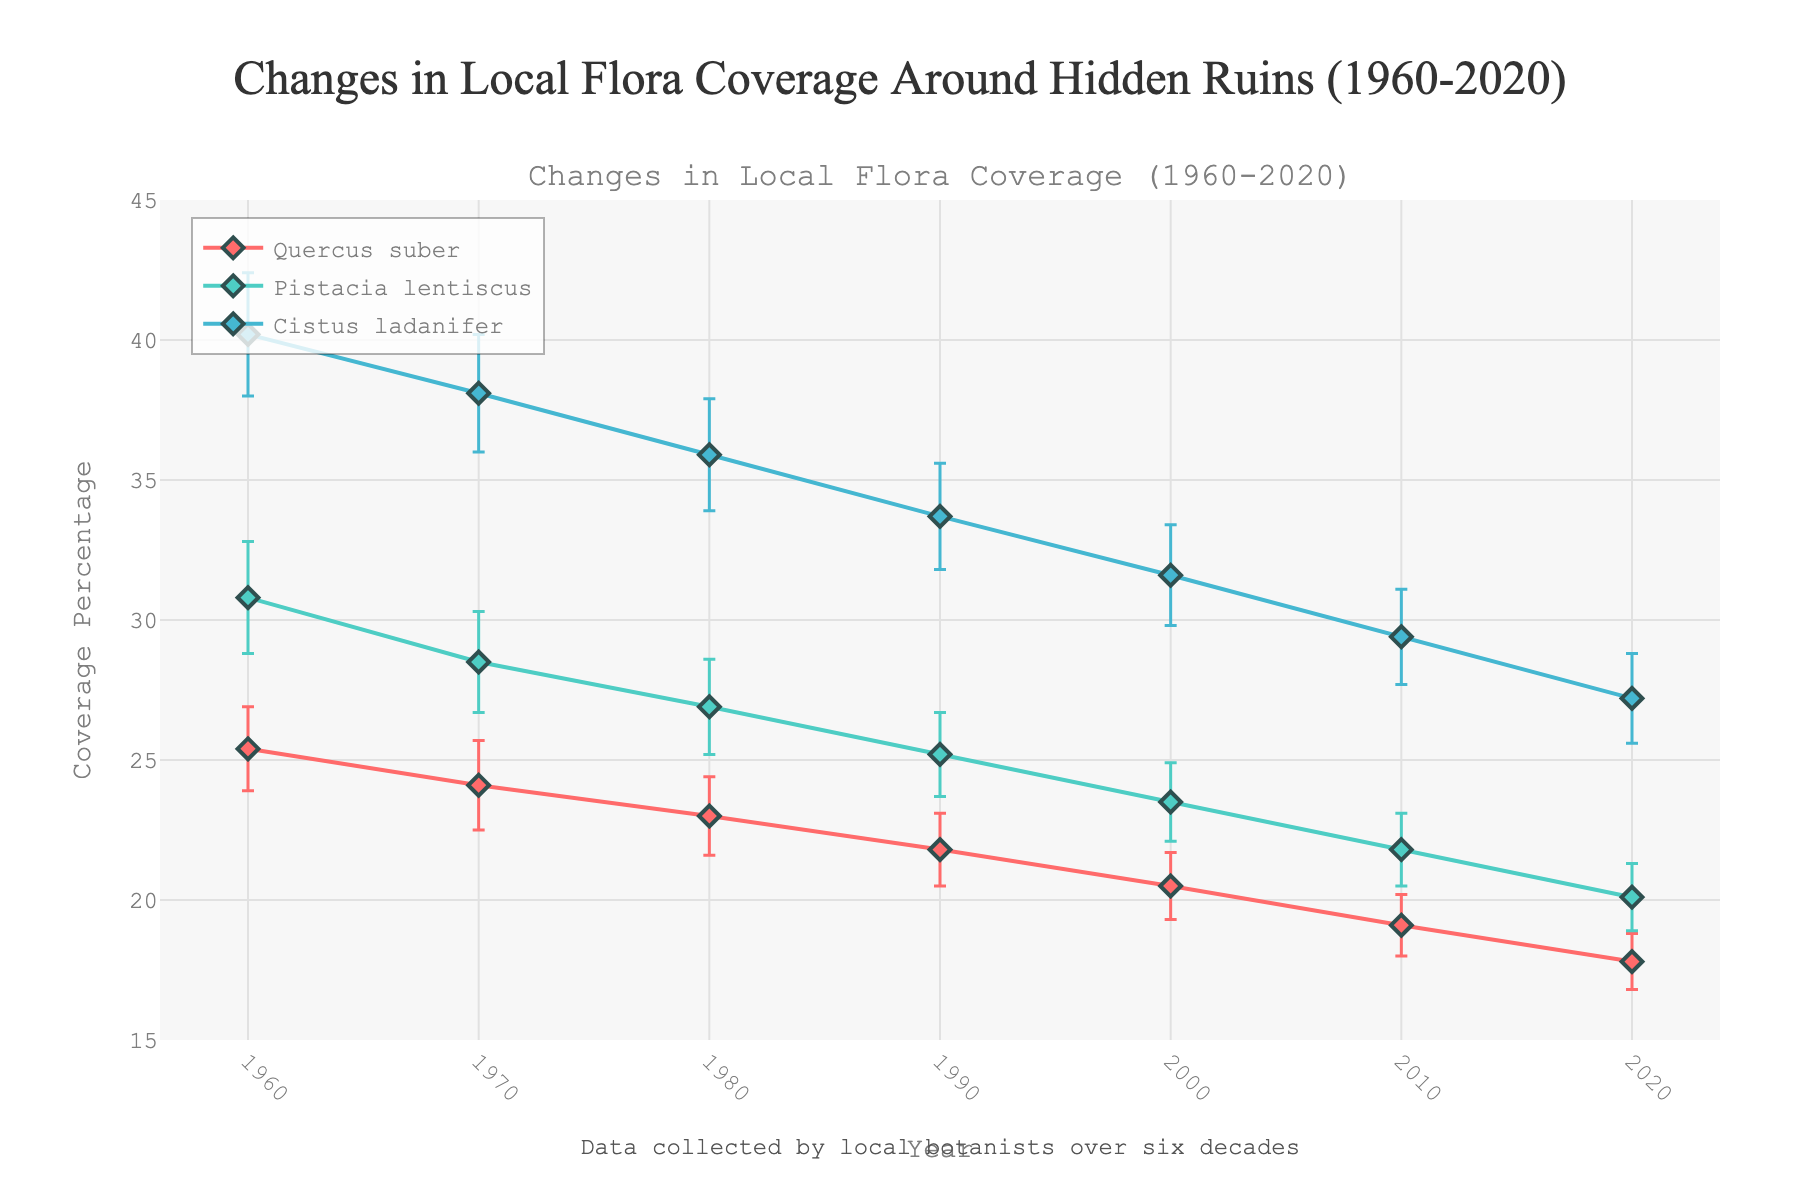How many flora species are tracked in the plot? Count the number of distinct lines in the figure, each representing a different flora species.
Answer: 3 What is the general trend in the coverage percentage of "Quercus suber" from 1960 to 2020? Observe the line for "Quercus suber" and see if it increases, decreases, or stays the same over time.
Answer: Decreasing In which decade did "Cistus ladanifer" have the highest mean coverage percentage? Identify the highest point on the "Cistus ladanifer" line and note the corresponding decade.
Answer: 1960s Among the three species, which had the smallest mean coverage percentage in 2020? Compare the coverage percentages for 2020 for all three species.
Answer: Quercus suber How much did the mean coverage percentage of "Pistacia lentiscus" change from 1960 to 1980? Calculate the difference between the 1960 mean coverage percentage and the 1980 mean coverage percentage for "Pistacia lentiscus".
Answer: 3.9% How does the error margin for "Cistus ladanifer" in 1990 compare to that in 2020? Compare the error margins provided for "Cistus ladanifer" in the years 1990 and 2020.
Answer: Lower in 1990 Which flora species has the most consistent mean coverage percentage over the decades? Identify the species with the smallest range in mean coverage percentage across all decades.
Answer: Quercus suber By how much did the mean coverage percentage of "Cistus ladanifer" decrease from 1960 to 2020? Subtract the 2020 mean coverage percentage from the 1960 value for "Cistus ladanifer".
Answer: 13% What is the main title of the plot? Locate and read the main title of the figure.
Answer: Changes in Local Flora Coverage Around Hidden Ruins (1960-2020) What is the error margin for "Quercus suber" in 1980? Point out the error margin value associated with the 1980 data point for "Quercus suber".
Answer: 1.4% 